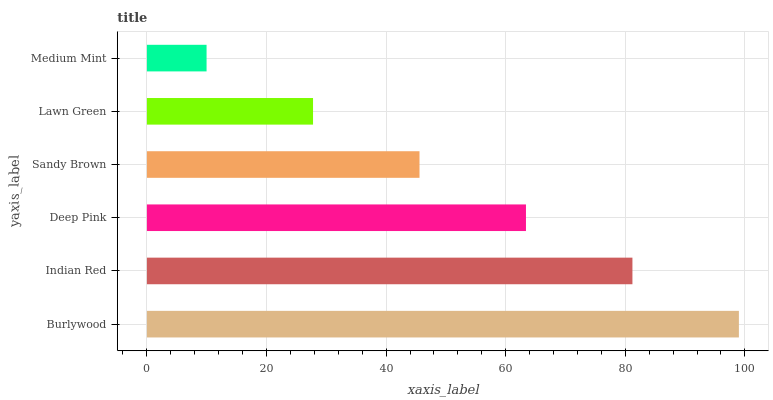Is Medium Mint the minimum?
Answer yes or no. Yes. Is Burlywood the maximum?
Answer yes or no. Yes. Is Indian Red the minimum?
Answer yes or no. No. Is Indian Red the maximum?
Answer yes or no. No. Is Burlywood greater than Indian Red?
Answer yes or no. Yes. Is Indian Red less than Burlywood?
Answer yes or no. Yes. Is Indian Red greater than Burlywood?
Answer yes or no. No. Is Burlywood less than Indian Red?
Answer yes or no. No. Is Deep Pink the high median?
Answer yes or no. Yes. Is Sandy Brown the low median?
Answer yes or no. Yes. Is Sandy Brown the high median?
Answer yes or no. No. Is Lawn Green the low median?
Answer yes or no. No. 